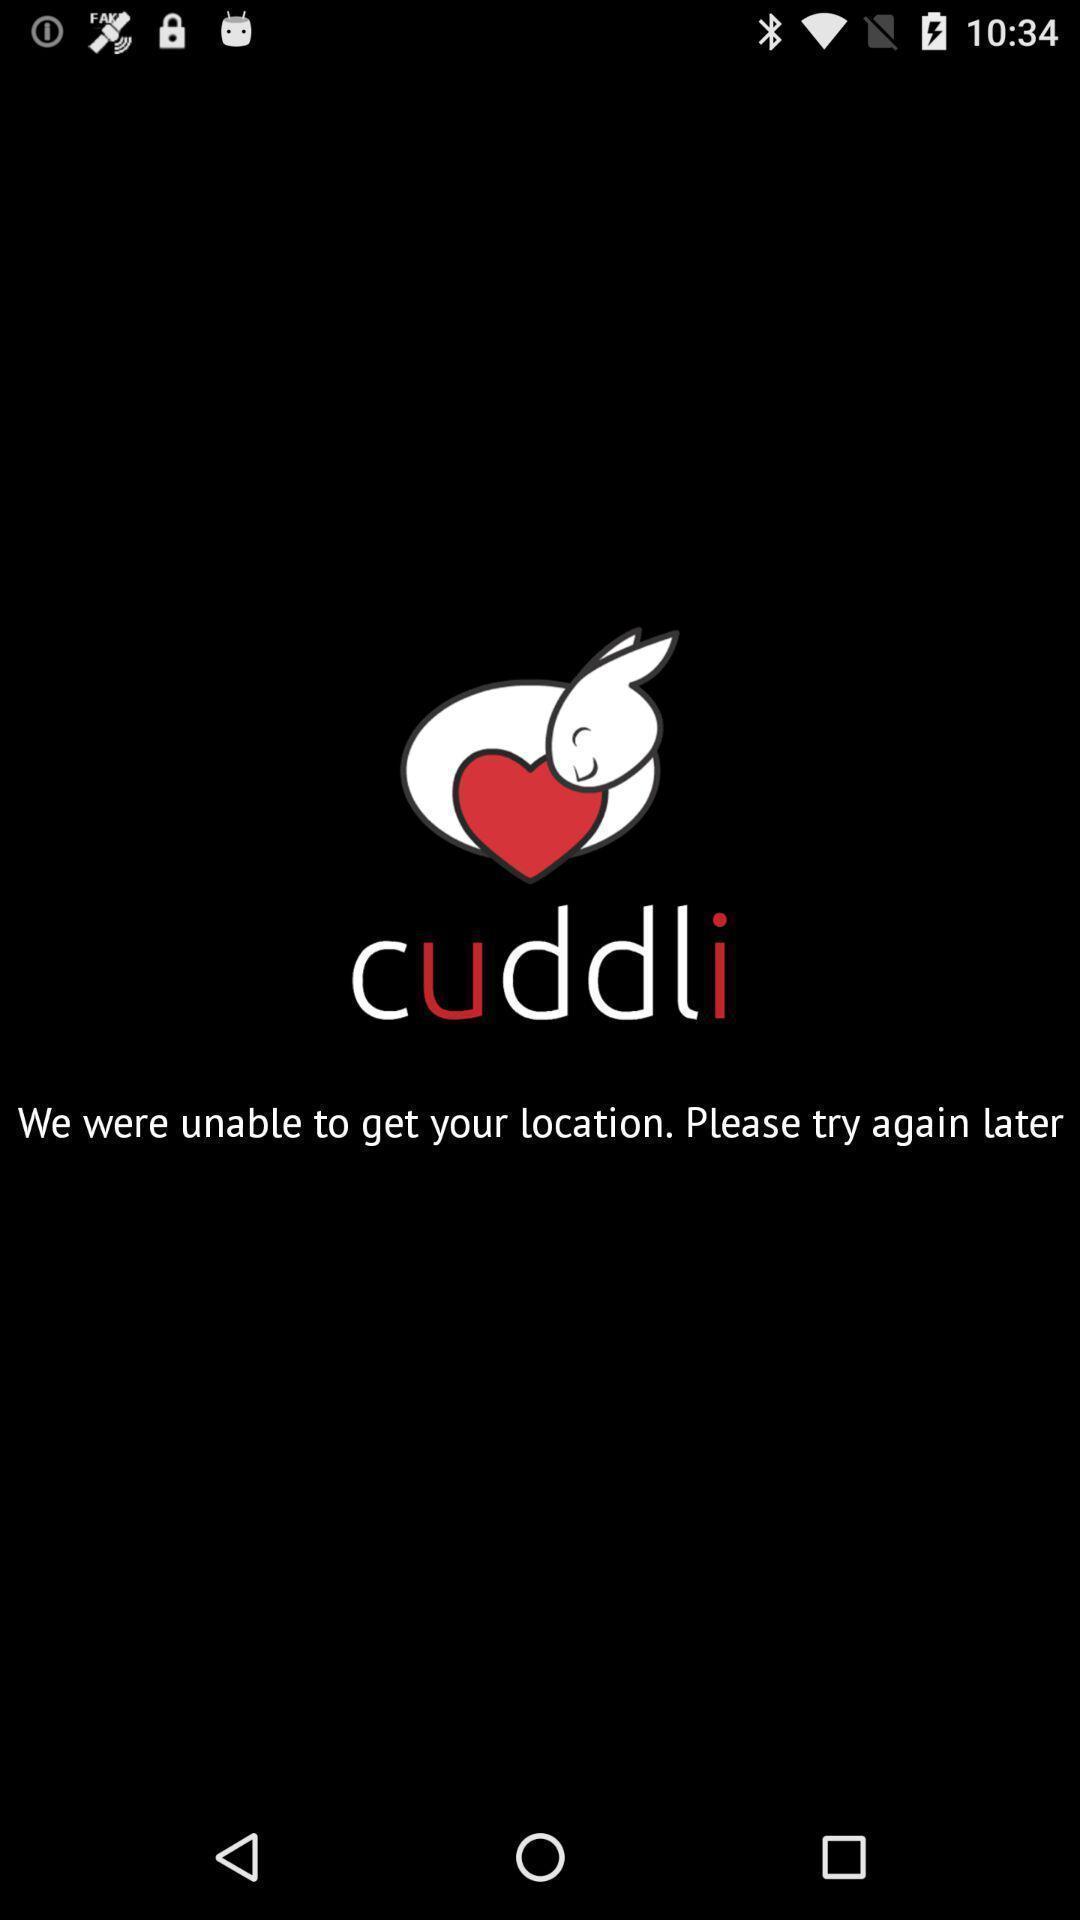Explain what's happening in this screen capture. Screen shows to add a location. 